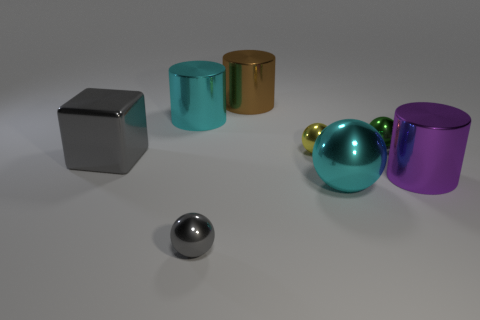How many other things are there of the same size as the purple thing?
Your answer should be very brief. 4. What is the size of the green sphere?
Ensure brevity in your answer.  Small. Does the big purple cylinder have the same material as the large cyan object that is to the left of the small yellow object?
Make the answer very short. Yes. Is there another large metallic object that has the same shape as the big purple thing?
Offer a terse response. Yes. There is a yellow object that is the same size as the green thing; what is it made of?
Ensure brevity in your answer.  Metal. There is a thing that is to the right of the green object; what size is it?
Ensure brevity in your answer.  Large. There is a cyan shiny thing that is left of the big brown metal cylinder; is it the same size as the shiny sphere to the left of the brown metal thing?
Your answer should be very brief. No. What number of big cyan cylinders have the same material as the cyan sphere?
Provide a succinct answer. 1. The large ball is what color?
Offer a terse response. Cyan. There is a large shiny sphere; are there any gray things in front of it?
Give a very brief answer. Yes. 